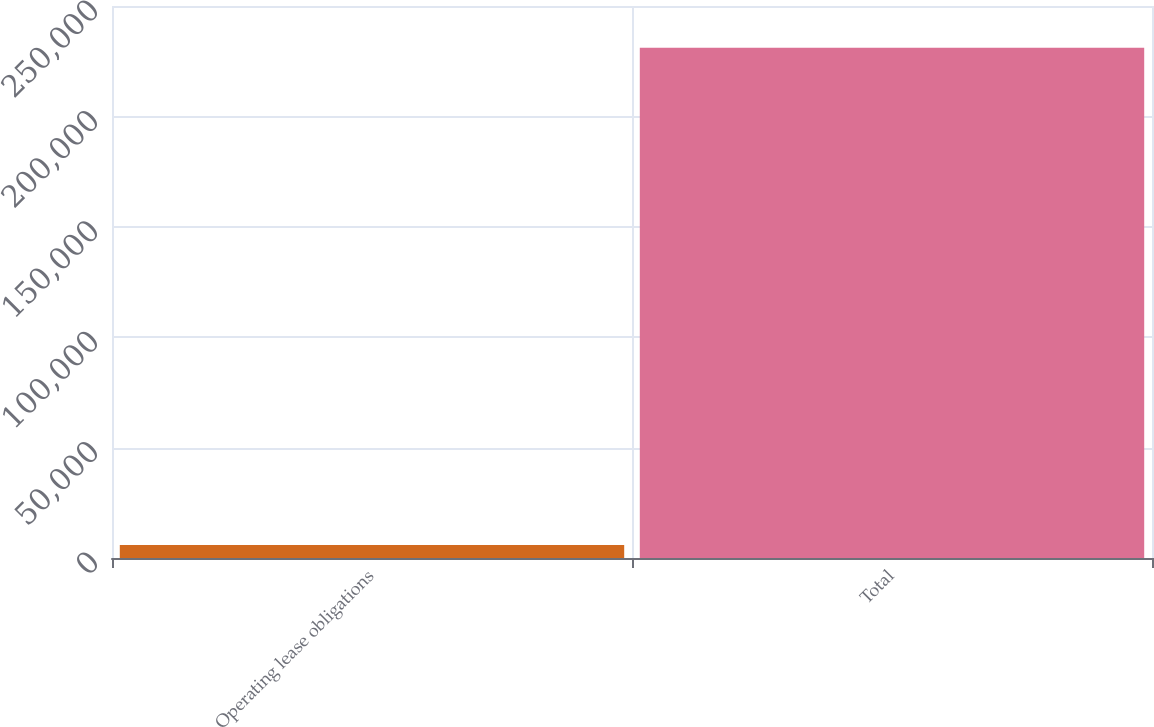Convert chart to OTSL. <chart><loc_0><loc_0><loc_500><loc_500><bar_chart><fcel>Operating lease obligations<fcel>Total<nl><fcel>5851<fcel>231064<nl></chart> 